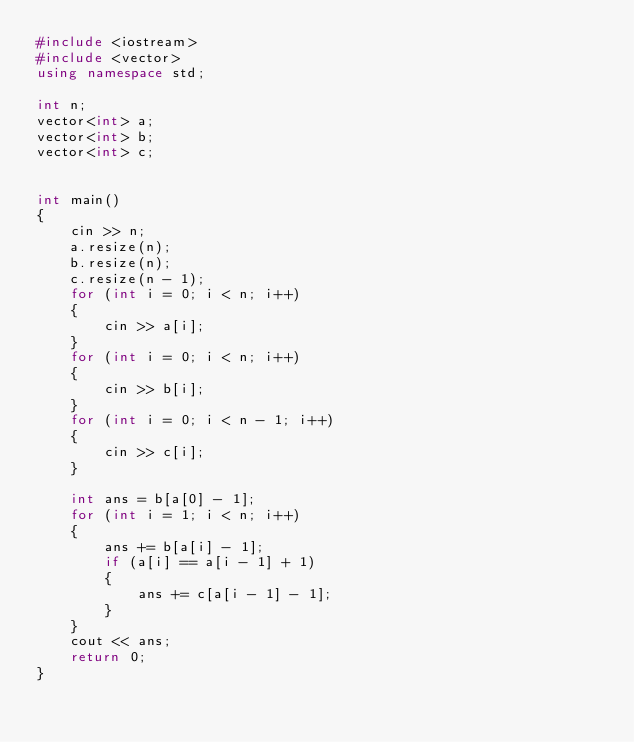<code> <loc_0><loc_0><loc_500><loc_500><_C++_>#include <iostream>
#include <vector>
using namespace std;

int n;
vector<int> a;
vector<int> b;
vector<int> c;


int main()
{
	cin >> n;
	a.resize(n);
	b.resize(n);
	c.resize(n - 1);
	for (int i = 0; i < n; i++)
	{
		cin >> a[i];
	}
	for (int i = 0; i < n; i++)
	{
		cin >> b[i];
	}
	for (int i = 0; i < n - 1; i++)
	{
		cin >> c[i];
	}
    
    int ans = b[a[0] - 1];
    for (int i = 1; i < n; i++)
    {
        ans += b[a[i] - 1];
        if (a[i] == a[i - 1] + 1)
        {
            ans += c[a[i - 1] - 1];
        }
    }
    cout << ans;
	return 0;
}</code> 